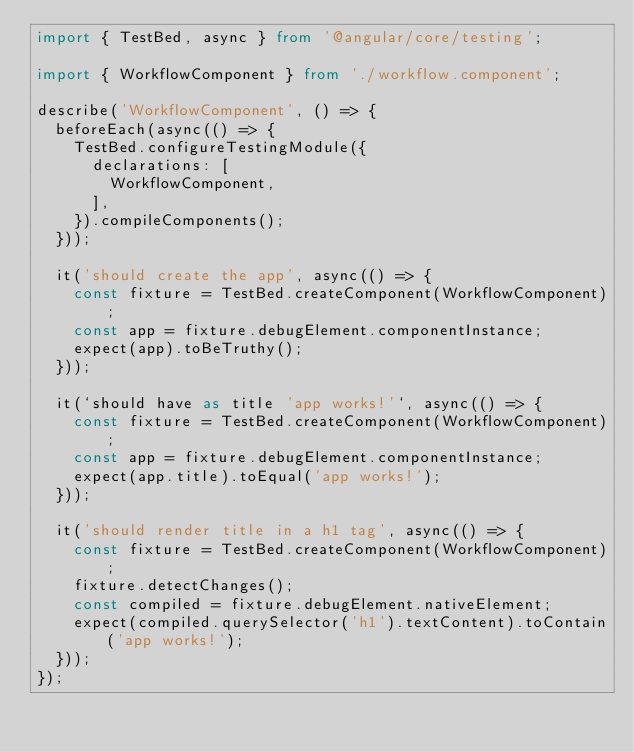<code> <loc_0><loc_0><loc_500><loc_500><_TypeScript_>import { TestBed, async } from '@angular/core/testing';

import { WorkflowComponent } from './workflow.component';

describe('WorkflowComponent', () => {
  beforeEach(async(() => {
    TestBed.configureTestingModule({
      declarations: [
        WorkflowComponent,
      ],
    }).compileComponents();
  }));

  it('should create the app', async(() => {
    const fixture = TestBed.createComponent(WorkflowComponent);
    const app = fixture.debugElement.componentInstance;
    expect(app).toBeTruthy();
  }));

  it(`should have as title 'app works!'`, async(() => {
    const fixture = TestBed.createComponent(WorkflowComponent);
    const app = fixture.debugElement.componentInstance;
    expect(app.title).toEqual('app works!');
  }));

  it('should render title in a h1 tag', async(() => {
    const fixture = TestBed.createComponent(WorkflowComponent);
    fixture.detectChanges();
    const compiled = fixture.debugElement.nativeElement;
    expect(compiled.querySelector('h1').textContent).toContain('app works!');
  }));
});
</code> 